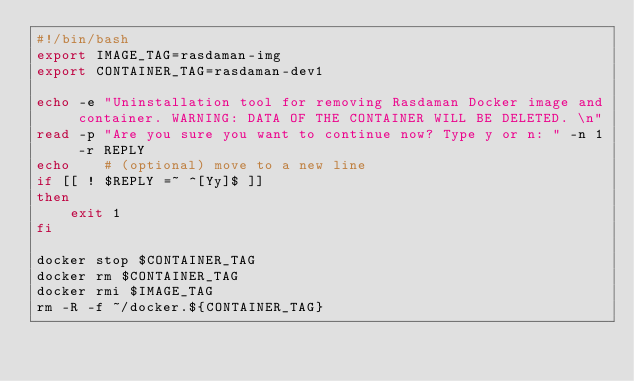Convert code to text. <code><loc_0><loc_0><loc_500><loc_500><_Bash_>#!/bin/bash
export IMAGE_TAG=rasdaman-img
export CONTAINER_TAG=rasdaman-dev1

echo -e "Uninstallation tool for removing Rasdaman Docker image and container. WARNING: DATA OF THE CONTAINER WILL BE DELETED. \n"
read -p "Are you sure you want to continue now? Type y or n: " -n 1 -r REPLY
echo    # (optional) move to a new line
if [[ ! $REPLY =~ ^[Yy]$ ]]
then
    exit 1
fi

docker stop $CONTAINER_TAG
docker rm $CONTAINER_TAG
docker rmi $IMAGE_TAG
rm -R -f ~/docker.${CONTAINER_TAG}
</code> 